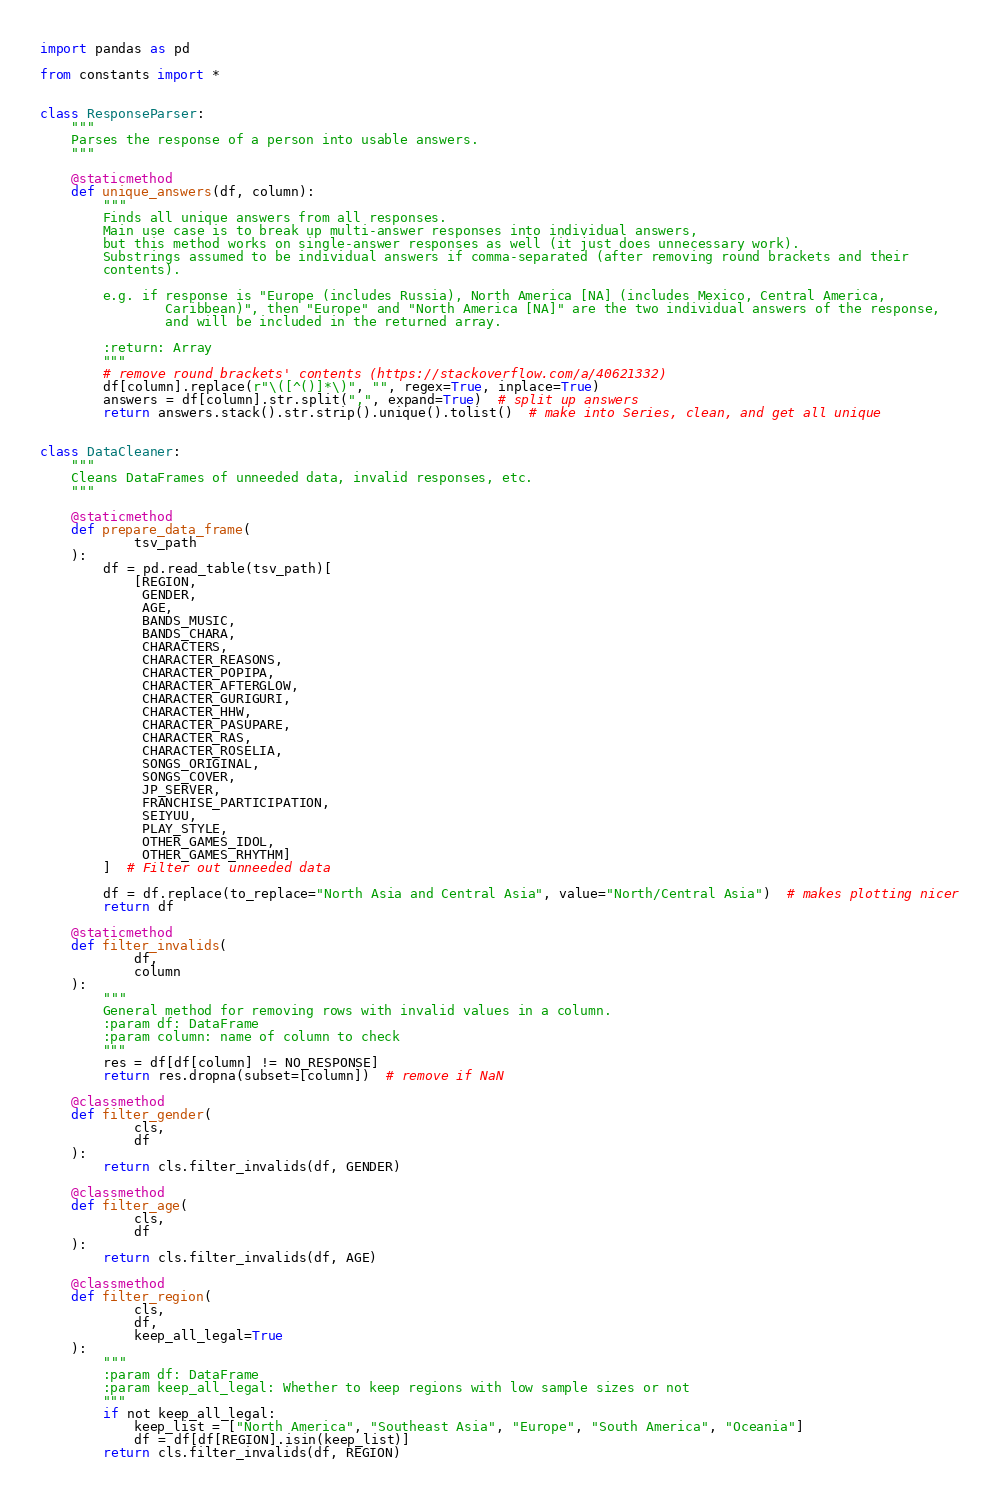<code> <loc_0><loc_0><loc_500><loc_500><_Python_>import pandas as pd

from constants import *


class ResponseParser:
    """
    Parses the response of a person into usable answers.
    """

    @staticmethod
    def unique_answers(df, column):
        """
        Finds all unique answers from all responses.
        Main use case is to break up multi-answer responses into individual answers,
        but this method works on single-answer responses as well (it just does unnecessary work).
        Substrings assumed to be individual answers if comma-separated (after removing round brackets and their
        contents).

        e.g. if response is "Europe (includes Russia), North America [NA] (includes Mexico, Central America,
                Caribbean)", then "Europe" and "North America [NA]" are the two individual answers of the response,
                and will be included in the returned array.

        :return: Array
        """
        # remove round brackets' contents (https://stackoverflow.com/a/40621332)
        df[column].replace(r"\([^()]*\)", "", regex=True, inplace=True)
        answers = df[column].str.split(",", expand=True)  # split up answers
        return answers.stack().str.strip().unique().tolist()  # make into Series, clean, and get all unique


class DataCleaner:
    """
    Cleans DataFrames of unneeded data, invalid responses, etc.
    """

    @staticmethod
    def prepare_data_frame(
            tsv_path
    ):
        df = pd.read_table(tsv_path)[
            [REGION,
             GENDER,
             AGE,
             BANDS_MUSIC,
             BANDS_CHARA,
             CHARACTERS,
             CHARACTER_REASONS,
             CHARACTER_POPIPA,
             CHARACTER_AFTERGLOW,
             CHARACTER_GURIGURI,
             CHARACTER_HHW,
             CHARACTER_PASUPARE,
             CHARACTER_RAS,
             CHARACTER_ROSELIA,
             SONGS_ORIGINAL,
             SONGS_COVER,
             JP_SERVER,
             FRANCHISE_PARTICIPATION,
             SEIYUU,
             PLAY_STYLE,
             OTHER_GAMES_IDOL,
             OTHER_GAMES_RHYTHM]
        ]  # Filter out unneeded data

        df = df.replace(to_replace="North Asia and Central Asia", value="North/Central Asia")  # makes plotting nicer
        return df

    @staticmethod
    def filter_invalids(
            df,
            column
    ):
        """
        General method for removing rows with invalid values in a column.
        :param df: DataFrame
        :param column: name of column to check
        """
        res = df[df[column] != NO_RESPONSE]
        return res.dropna(subset=[column])  # remove if NaN

    @classmethod
    def filter_gender(
            cls,
            df
    ):
        return cls.filter_invalids(df, GENDER)

    @classmethod
    def filter_age(
            cls,
            df
    ):
        return cls.filter_invalids(df, AGE)

    @classmethod
    def filter_region(
            cls,
            df,
            keep_all_legal=True
    ):
        """
        :param df: DataFrame
        :param keep_all_legal: Whether to keep regions with low sample sizes or not
        """
        if not keep_all_legal:
            keep_list = ["North America", "Southeast Asia", "Europe", "South America", "Oceania"]
            df = df[df[REGION].isin(keep_list)]
        return cls.filter_invalids(df, REGION)
</code> 